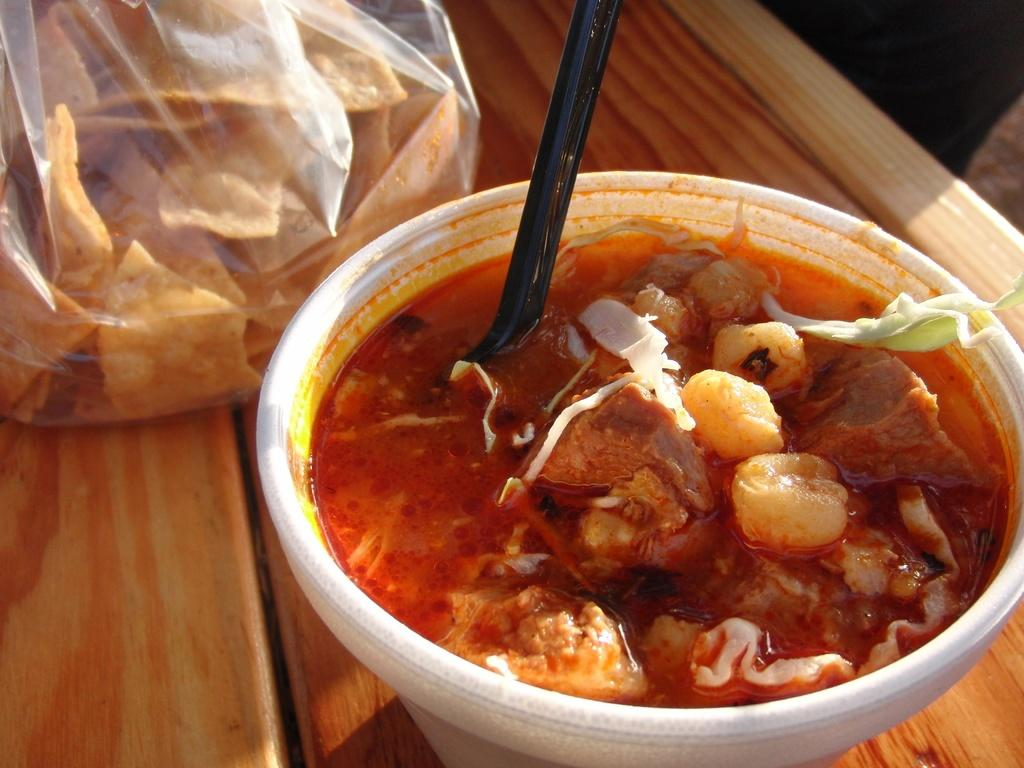What is in the bowl that is visible in the image? There is a bowl with food in the image. What utensil is present in the bowl? There is a spoon in the bowl. What else with food is visible in the image? There is a packet with food in the image. Where are the bowl and packet located? The bowl and packet are on a table. What disease is being cured by the food in the image? There is no indication in the image that the food is related to curing any disease. 